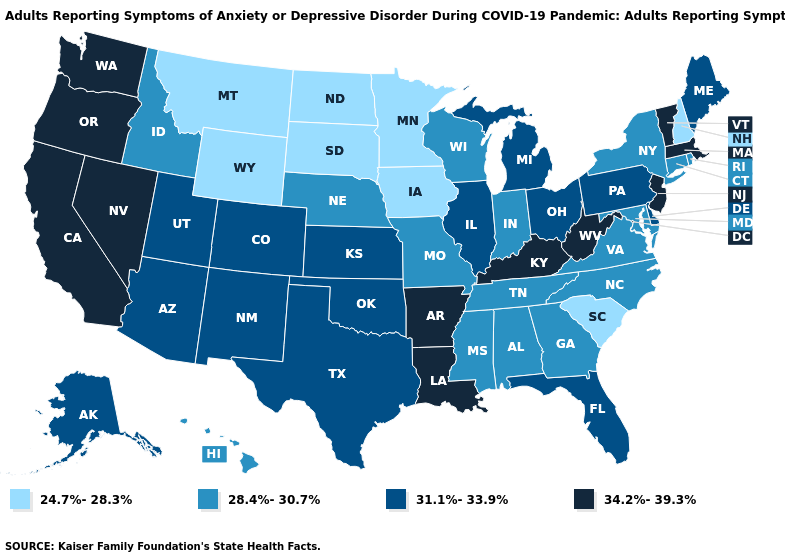What is the lowest value in the USA?
Keep it brief. 24.7%-28.3%. What is the value of Washington?
Concise answer only. 34.2%-39.3%. What is the value of West Virginia?
Keep it brief. 34.2%-39.3%. Does Maine have the lowest value in the USA?
Keep it brief. No. What is the highest value in the MidWest ?
Short answer required. 31.1%-33.9%. Name the states that have a value in the range 28.4%-30.7%?
Keep it brief. Alabama, Connecticut, Georgia, Hawaii, Idaho, Indiana, Maryland, Mississippi, Missouri, Nebraska, New York, North Carolina, Rhode Island, Tennessee, Virginia, Wisconsin. Name the states that have a value in the range 31.1%-33.9%?
Keep it brief. Alaska, Arizona, Colorado, Delaware, Florida, Illinois, Kansas, Maine, Michigan, New Mexico, Ohio, Oklahoma, Pennsylvania, Texas, Utah. Among the states that border Illinois , which have the highest value?
Concise answer only. Kentucky. What is the value of North Dakota?
Write a very short answer. 24.7%-28.3%. Which states have the lowest value in the MidWest?
Answer briefly. Iowa, Minnesota, North Dakota, South Dakota. Among the states that border Nevada , which have the lowest value?
Answer briefly. Idaho. Name the states that have a value in the range 31.1%-33.9%?
Keep it brief. Alaska, Arizona, Colorado, Delaware, Florida, Illinois, Kansas, Maine, Michigan, New Mexico, Ohio, Oklahoma, Pennsylvania, Texas, Utah. Among the states that border Nebraska , does Missouri have the highest value?
Quick response, please. No. What is the highest value in states that border Mississippi?
Be succinct. 34.2%-39.3%. Does Texas have the highest value in the South?
Keep it brief. No. 